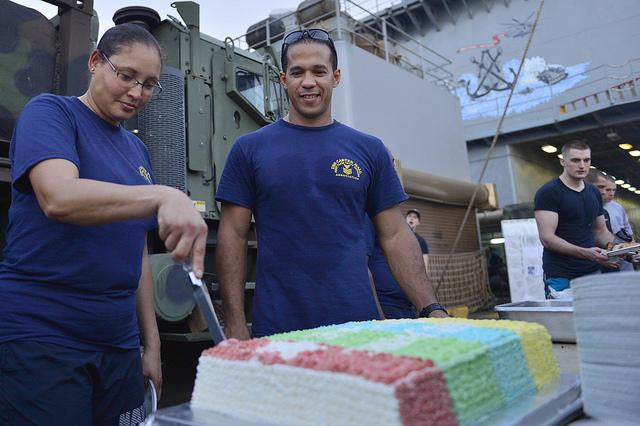What colors are the cake?
Quick response, please. Red, green, blue, yellow. What is the main color of their shirts?
Quick response, please. Blue. Are they cutting a birthday cake?
Quick response, please. Yes. 